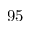<formula> <loc_0><loc_0><loc_500><loc_500>9 5</formula> 